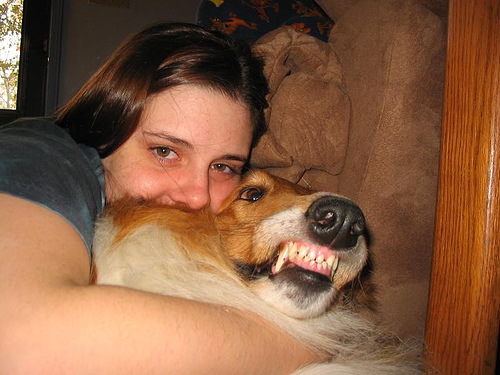<image>
Can you confirm if the dog is under the girl? Yes. The dog is positioned underneath the girl, with the girl above it in the vertical space. Is the girl in front of the dog? No. The girl is not in front of the dog. The spatial positioning shows a different relationship between these objects. 